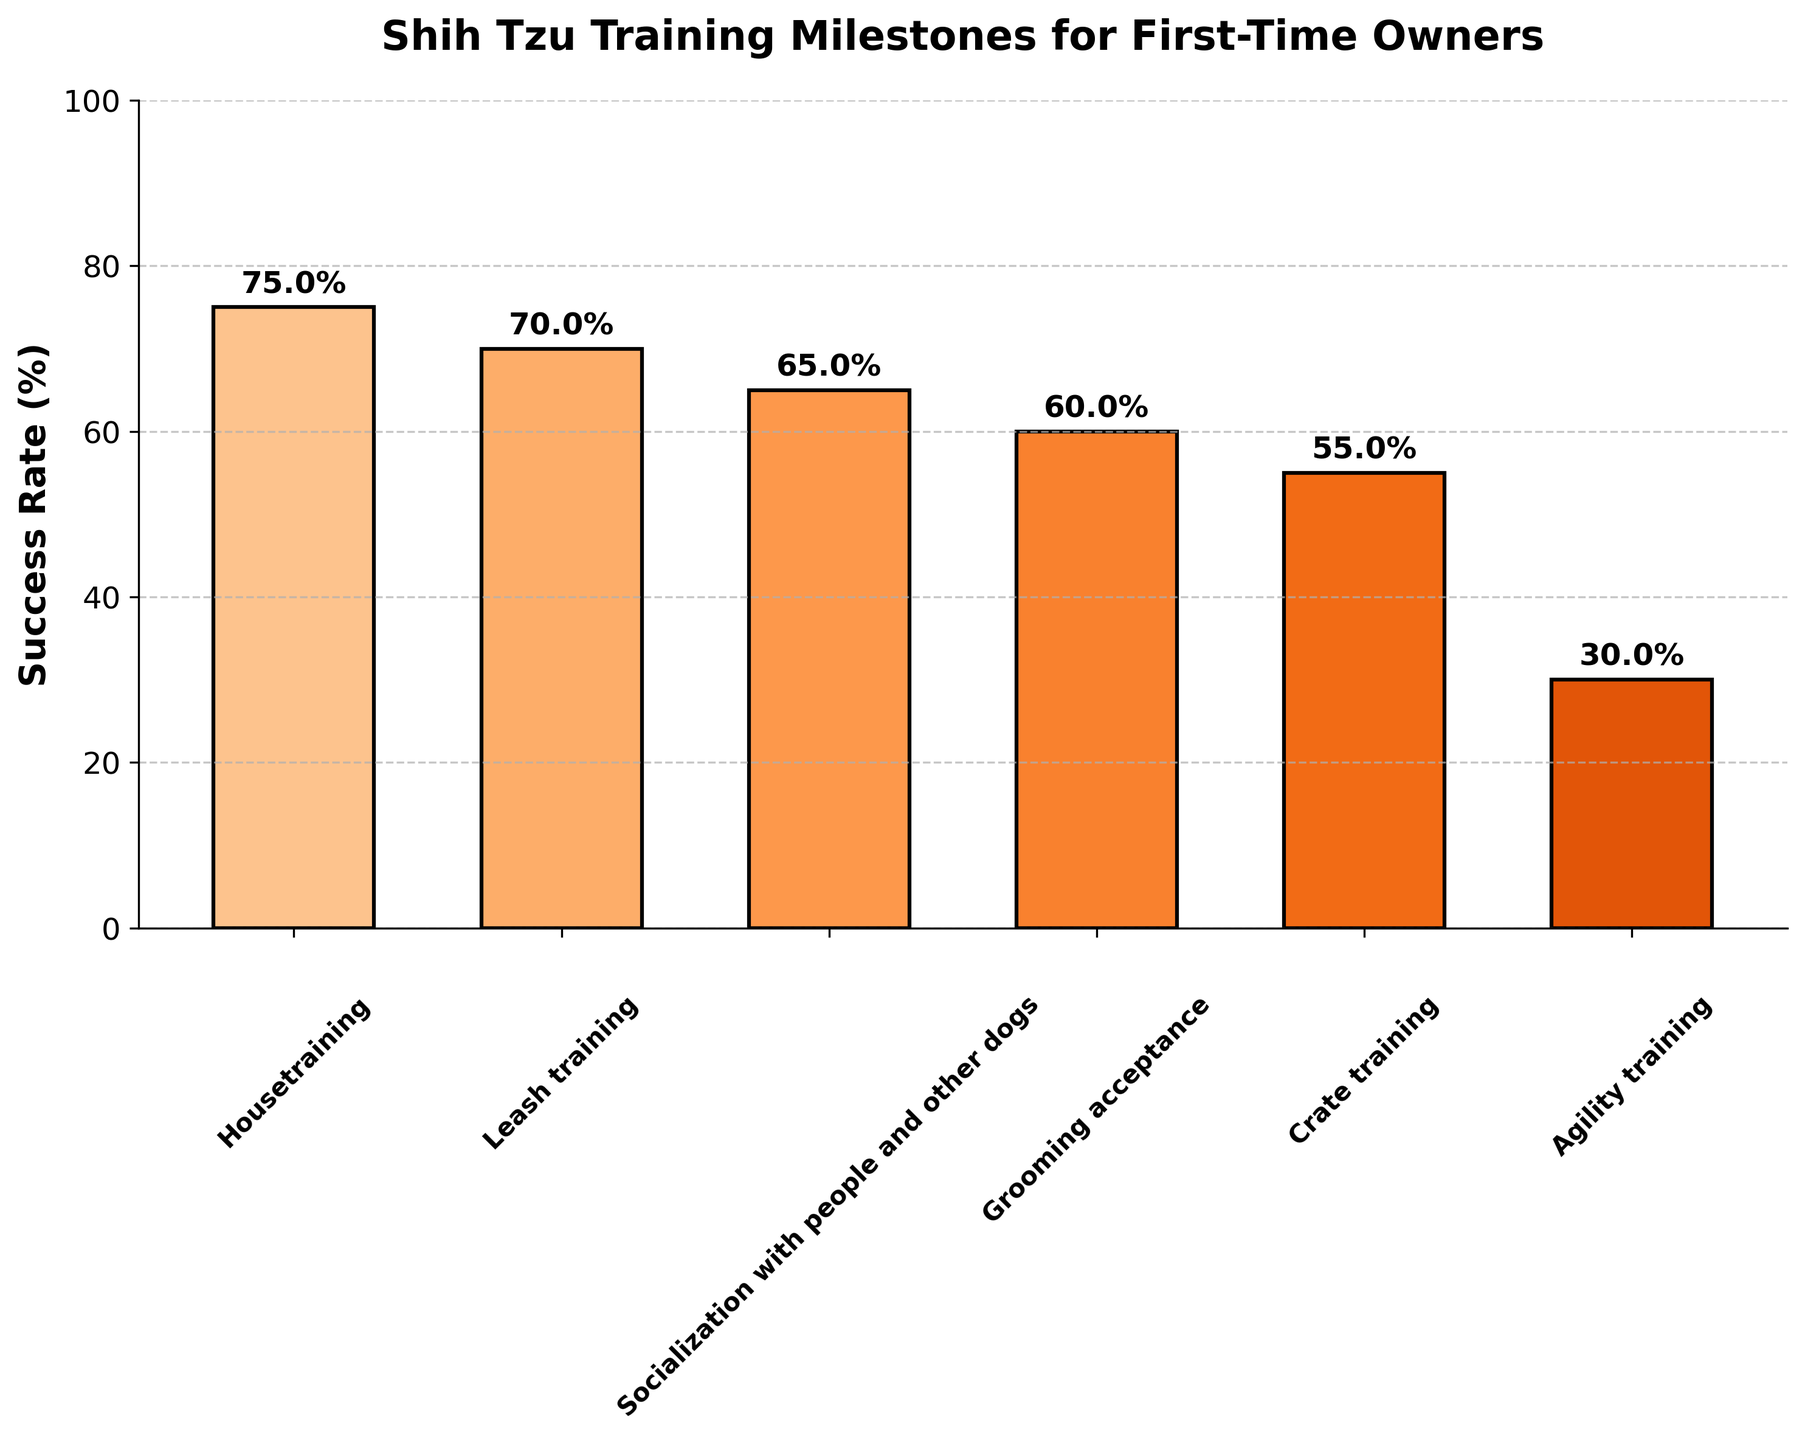what is the title of the figure? The title is located at the top of the figure and is prominently displayed. The title helps in understanding the overall topic or focus of the chart.
Answer: Shih Tzu Training Milestones for First-Time Owners what is the success rate for leash training? The success rate for each stage is displayed as a percentage on top of the corresponding bar. Look at the bar labeled "Leash training" and read the value above it.
Answer: 70% which stage has the lowest success rate? Identify the bar with the smallest height, representing the lowest success rate. Read the label associated with this bar to find the stage.
Answer: Agility training how many training stages are shown in the figure? Count the number of bars in the chart, each bar representing a different training stage.
Answer: 6 what is the difference in success rates between housetraining and crate training? Locate the success rates for both housetraining (75%) and crate training (55%). Subtract the success rate of crate training from that of housetraining: 75% - 55% = 20%.
Answer: 20% which stage has a higher success rate: grooming acceptance or socialization? Compare the success rates of grooming acceptance (60%) and socialization with people and other dogs (65%). Determine which value is greater.
Answer: Socialization with people and other dogs what are the success rates for the stages that involve training with equipment (leash and crate)? Identify the stages related to training with equipment, which are leash training and crate training. Read their success rates: Leash training (70%) and Crate training (55%).
Answer: 70% and 55% what is the average success rate for all training stages? Add up all the success rates for each stage: 75% + 70% + 65% + 60% + 55% + 30% = 355%. Divide by the number of stages: 355% / 6 = 59.17%.
Answer: 59.17% which stage has the second highest success rate? Rank all stages by their success rates in descending order. The stage with the second largest percentage is the one with the second highest success rate. Housetraining is first (75%), and Leash training is second (70%).
Answer: Leash training 